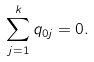<formula> <loc_0><loc_0><loc_500><loc_500>\sum _ { j = 1 } ^ { k } q _ { 0 j } = 0 .</formula> 